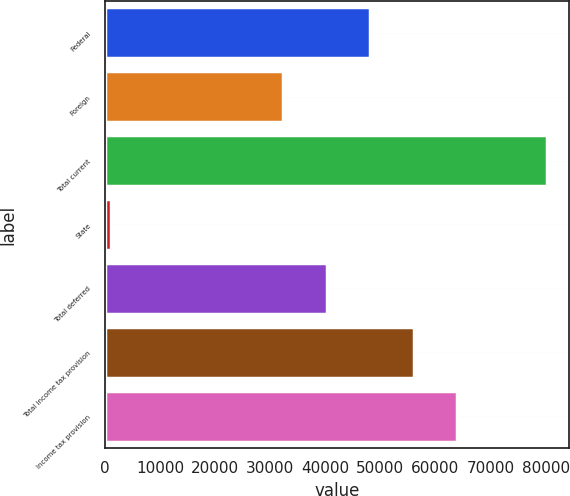Convert chart to OTSL. <chart><loc_0><loc_0><loc_500><loc_500><bar_chart><fcel>Federal<fcel>Foreign<fcel>Total current<fcel>State<fcel>Total deferred<fcel>Total income tax provision<fcel>Income tax provision<nl><fcel>48162.8<fcel>32341<fcel>80193<fcel>1084<fcel>40251.9<fcel>56073.7<fcel>63984.6<nl></chart> 